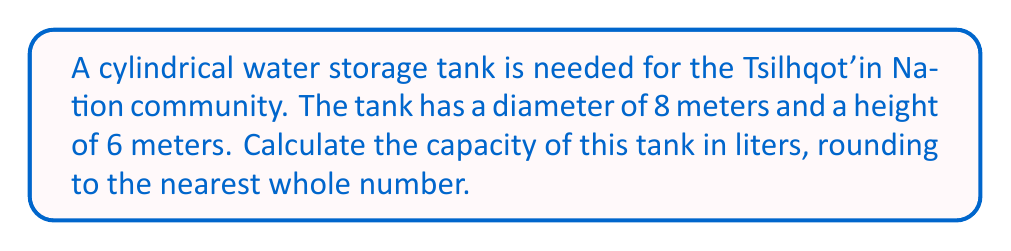Teach me how to tackle this problem. To solve this problem, we'll follow these steps:

1) The volume of a cylinder is given by the formula:
   $$V = \pi r^2 h$$
   where $r$ is the radius and $h$ is the height.

2) We're given the diameter (8 meters), so we need to halve this to get the radius:
   $$r = 8 \div 2 = 4$$ meters

3) Now we can substitute our values into the formula:
   $$V = \pi (4\text{ m})^2 (6\text{ m})$$

4) Simplify:
   $$V = \pi (16\text{ m}^2) (6\text{ m}) = 96\pi\text{ m}^3$$

5) Calculate:
   $$V \approx 301.59\text{ m}^3$$

6) Convert cubic meters to liters:
   1 cubic meter = 1000 liters
   $$301.59\text{ m}^3 \times 1000\text{ L/m}^3 = 301,590\text{ L}$$

7) Rounding to the nearest whole number:
   301,590 liters

This is the capacity of the cylindrical water storage tank.
Answer: 301,590 liters 